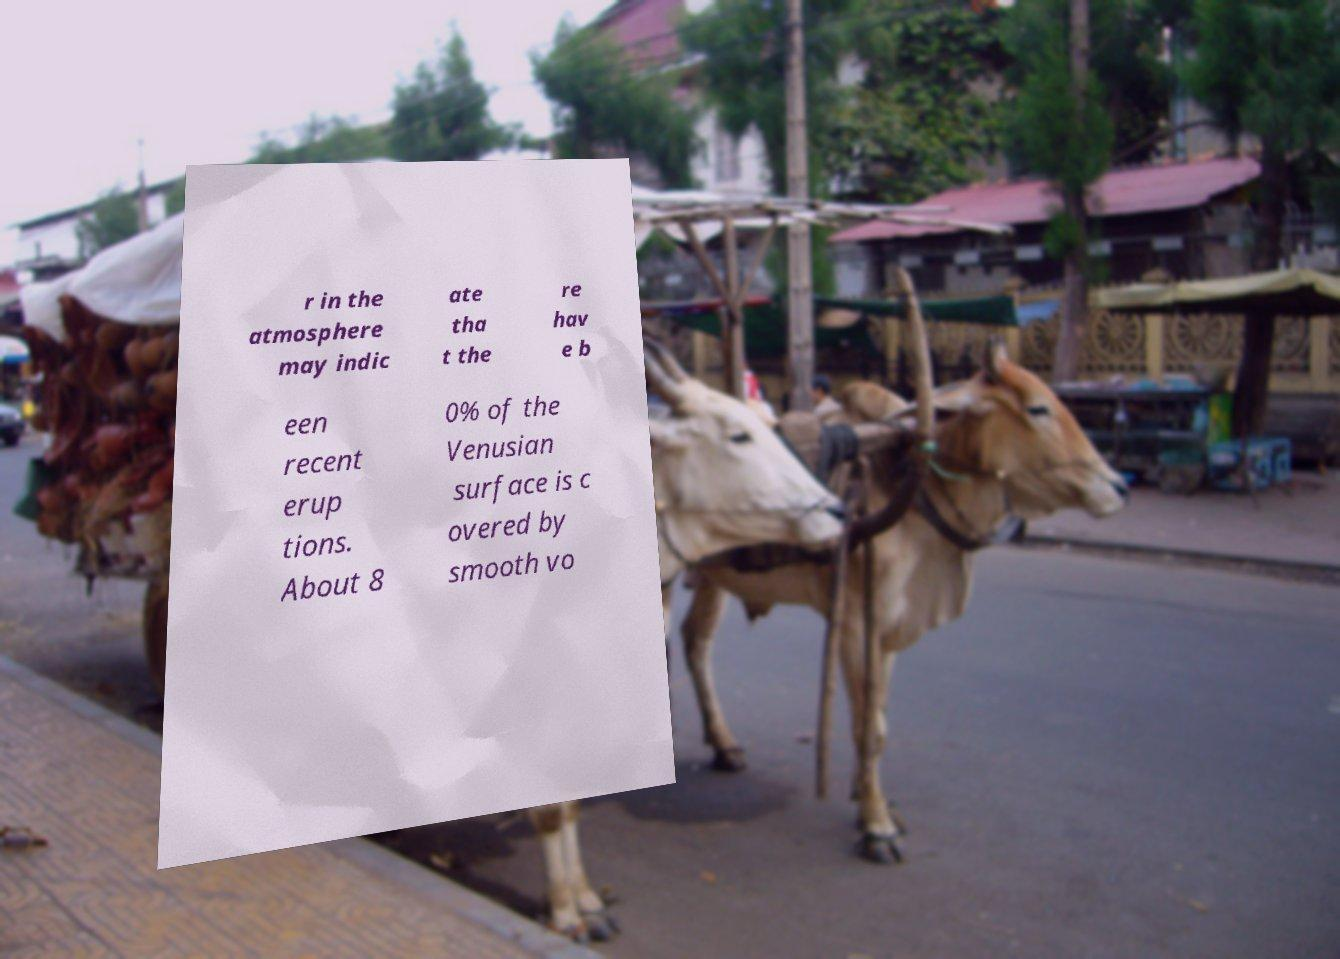For documentation purposes, I need the text within this image transcribed. Could you provide that? r in the atmosphere may indic ate tha t the re hav e b een recent erup tions. About 8 0% of the Venusian surface is c overed by smooth vo 